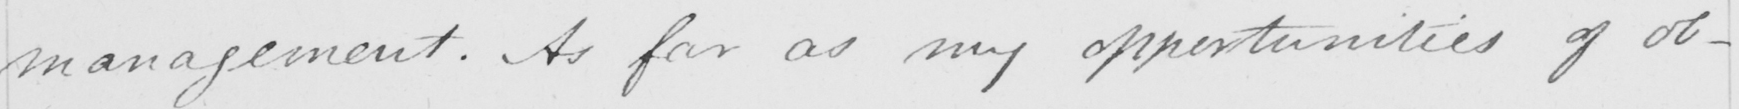Transcribe the text shown in this historical manuscript line. management . As far as my opportunities of ob- 